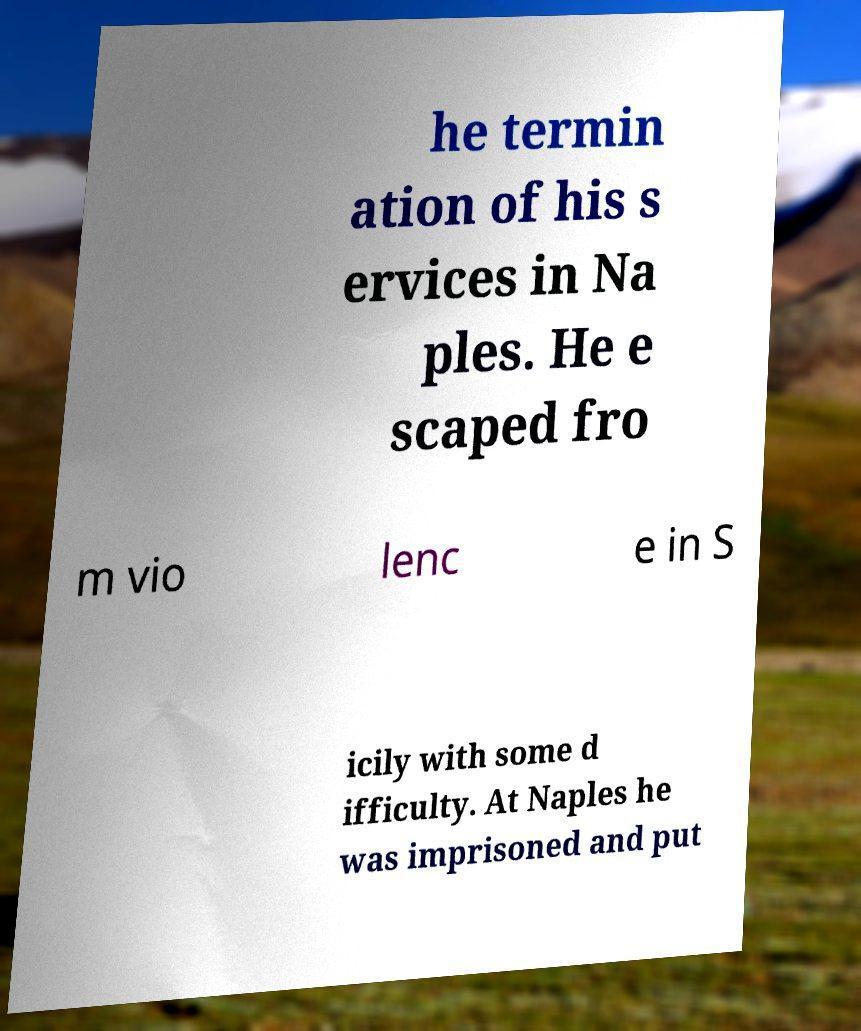Could you extract and type out the text from this image? he termin ation of his s ervices in Na ples. He e scaped fro m vio lenc e in S icily with some d ifficulty. At Naples he was imprisoned and put 